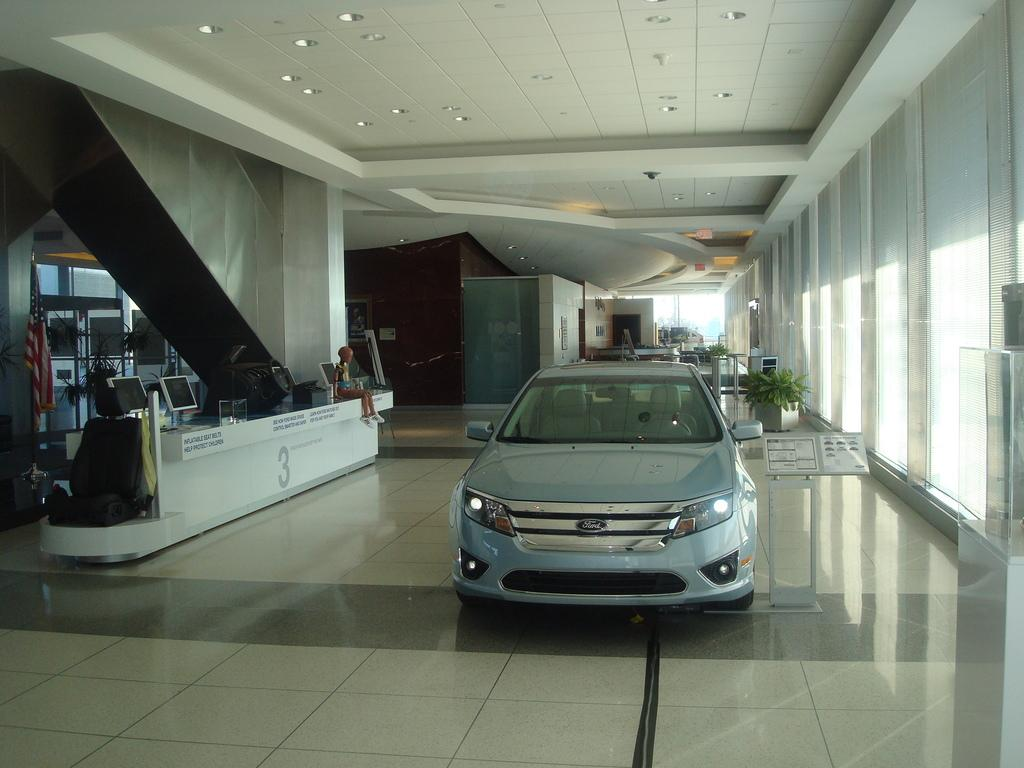What object is placed on the floor in the image? There is a car on the floor in the image. What electronic devices can be seen in the image? There are monitors in the image. What type of furniture is present in the image? There is a seat in the image. What type of plants are in the image? House plants are present in the image. What structure is used to hold or display items in the image? There is a stand in the image. What type of machine is visible in the image? A robot is visible in the image. What is on the wall in the background of the image? There is a poster on the wall in the background of the image. Can you see a monkey interacting with the robot in the image? There is no monkey present in the image. --- Facts: 1. There is a person in the image. 12. The person is wearing a hat. 13. The person is holding a book. 14. There is a table in the image. 15. There is a chair in the image. Absurd Topics: elephant, piano, shoes Conversation: Who or what is present in the image? There is a person in the image. What is the person wearing on their head? The person is wearing a hat. What is the person holding in their hands? The person is holding a book. What type of furniture is present in the image? There is a table in the image. What type of seating furniture is present in the image? There is a chair in the image. Reasoning: Let's think step by step in order to produce the conversation. We start by identifying the main subject in the image, which is the person. Then, we describe specific features of the person, such as the hat and the book they are holding. Next, we observe the furniture in the image, noting that there is a table and a chair. Each question is designed to elicit a specific detail about the image that is known from the provided facts. We avoid yes/no questions and ensure that the language is simple and clear. Absurd Question/Answer: Can you hear the elephant playing the piano in the image? There is no elephant or piano present in the image. --- Facts: 1. There is a dog in the image. 12. The dog is lying down. 13. The dog is wagging its tail. 14. There is a bowl of water in the image. 15. There is a patch of grass in the image. Absurd Topics: ice cream, bicycle, umbrella Conversation: What type of animal is present in the image? There is a dog in the image. What position is the dog in? The dog is lying down. 